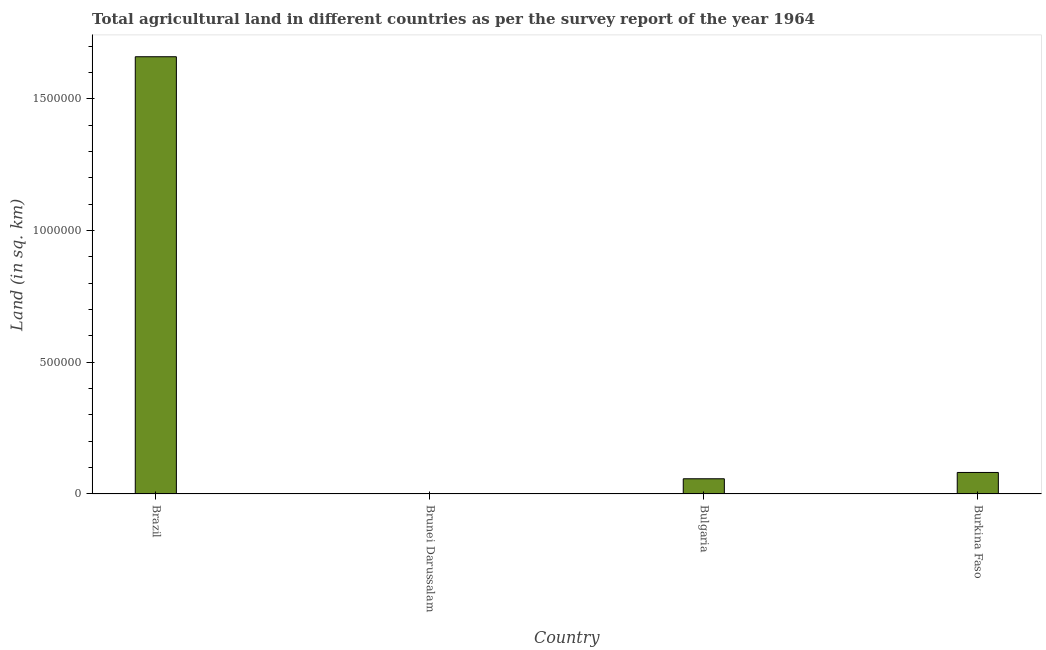Does the graph contain any zero values?
Give a very brief answer. No. Does the graph contain grids?
Keep it short and to the point. No. What is the title of the graph?
Make the answer very short. Total agricultural land in different countries as per the survey report of the year 1964. What is the label or title of the Y-axis?
Your response must be concise. Land (in sq. km). What is the agricultural land in Brazil?
Provide a succinct answer. 1.66e+06. Across all countries, what is the maximum agricultural land?
Your response must be concise. 1.66e+06. Across all countries, what is the minimum agricultural land?
Your answer should be compact. 240. In which country was the agricultural land maximum?
Give a very brief answer. Brazil. In which country was the agricultural land minimum?
Offer a very short reply. Brunei Darussalam. What is the sum of the agricultural land?
Provide a succinct answer. 1.80e+06. What is the difference between the agricultural land in Brazil and Burkina Faso?
Keep it short and to the point. 1.58e+06. What is the average agricultural land per country?
Keep it short and to the point. 4.50e+05. What is the median agricultural land?
Offer a very short reply. 6.97e+04. What is the ratio of the agricultural land in Brazil to that in Brunei Darussalam?
Provide a succinct answer. 6918.38. Is the difference between the agricultural land in Brazil and Burkina Faso greater than the difference between any two countries?
Give a very brief answer. No. What is the difference between the highest and the second highest agricultural land?
Offer a very short reply. 1.58e+06. Is the sum of the agricultural land in Brazil and Bulgaria greater than the maximum agricultural land across all countries?
Keep it short and to the point. Yes. What is the difference between the highest and the lowest agricultural land?
Ensure brevity in your answer.  1.66e+06. How many bars are there?
Your answer should be compact. 4. Are the values on the major ticks of Y-axis written in scientific E-notation?
Provide a succinct answer. No. What is the Land (in sq. km) of Brazil?
Keep it short and to the point. 1.66e+06. What is the Land (in sq. km) in Brunei Darussalam?
Ensure brevity in your answer.  240. What is the Land (in sq. km) in Bulgaria?
Offer a very short reply. 5.77e+04. What is the Land (in sq. km) of Burkina Faso?
Give a very brief answer. 8.17e+04. What is the difference between the Land (in sq. km) in Brazil and Brunei Darussalam?
Provide a succinct answer. 1.66e+06. What is the difference between the Land (in sq. km) in Brazil and Bulgaria?
Make the answer very short. 1.60e+06. What is the difference between the Land (in sq. km) in Brazil and Burkina Faso?
Offer a terse response. 1.58e+06. What is the difference between the Land (in sq. km) in Brunei Darussalam and Bulgaria?
Offer a very short reply. -5.75e+04. What is the difference between the Land (in sq. km) in Brunei Darussalam and Burkina Faso?
Ensure brevity in your answer.  -8.14e+04. What is the difference between the Land (in sq. km) in Bulgaria and Burkina Faso?
Provide a succinct answer. -2.40e+04. What is the ratio of the Land (in sq. km) in Brazil to that in Brunei Darussalam?
Provide a short and direct response. 6918.38. What is the ratio of the Land (in sq. km) in Brazil to that in Bulgaria?
Offer a terse response. 28.77. What is the ratio of the Land (in sq. km) in Brazil to that in Burkina Faso?
Your response must be concise. 20.33. What is the ratio of the Land (in sq. km) in Brunei Darussalam to that in Bulgaria?
Offer a very short reply. 0. What is the ratio of the Land (in sq. km) in Brunei Darussalam to that in Burkina Faso?
Your answer should be compact. 0. What is the ratio of the Land (in sq. km) in Bulgaria to that in Burkina Faso?
Give a very brief answer. 0.71. 